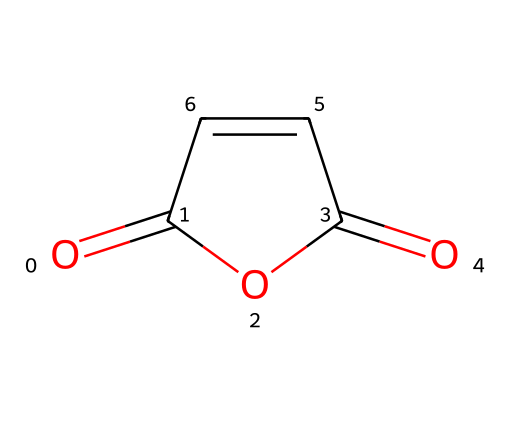What is the molecular formula of maleic anhydride? The SMILES representation indicates the presence of 4 carbon atoms (C), 4 oxygen atoms (O), and 2 hydrogen atoms (H). Combining these gives the molecular formula C4H2O3.
Answer: C4H2O3 How many double bonds are present in the structure? Analyzing the SMILES notation, there are two double bonds indicated – one between carbon and oxygen in the anhydride form and one between two carbon atoms.
Answer: 2 What is the functional group present in maleic anhydride? The structure contains an anhydride group, identified by the presence of carbonyl (C=O) adjacent to an ether-like oxygen (C-O-C) bond.
Answer: anhydride What is the shape of the maleic anhydride molecule? The arrangement of atoms and the presence of double bonds give maleic anhydride a planar structure, which is typical for compounds with conjugated double bonds.
Answer: planar What type of acid does maleic anhydride derive from? Maleic anhydride is derived from maleic acid, which contains the same carbon skeleton and functional groups but in a different structural arrangement.
Answer: maleic acid How does the presence of double bonds affect the reactivity of maleic anhydride in water treatment? The double bonds increase the electrophilic character of the compound, making it more reactive in addition reactions, which is beneficial in water treatment processes to form useful derivatives.
Answer: increases reactivity 